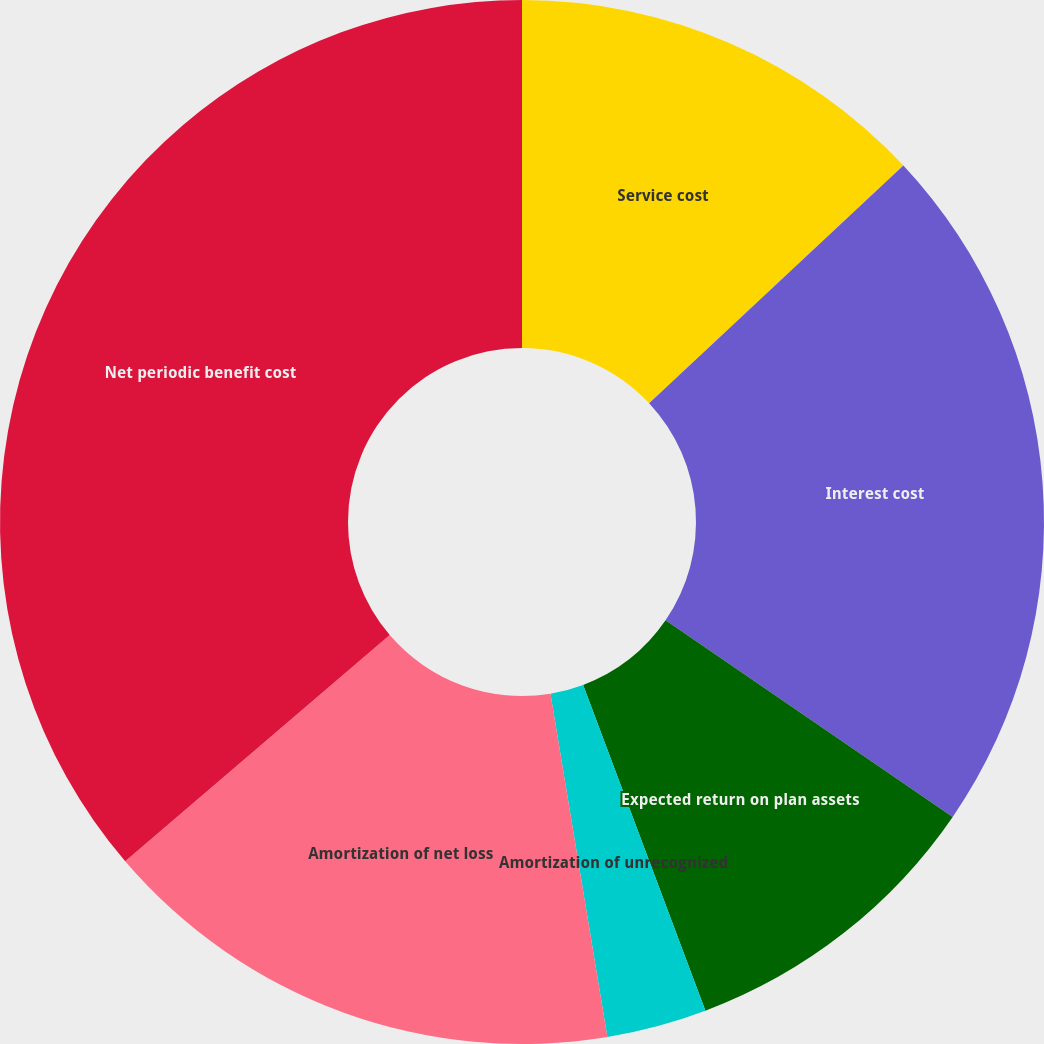<chart> <loc_0><loc_0><loc_500><loc_500><pie_chart><fcel>Service cost<fcel>Interest cost<fcel>Expected return on plan assets<fcel>Amortization of unrecognized<fcel>Amortization of net loss<fcel>Net periodic benefit cost<nl><fcel>13.04%<fcel>21.52%<fcel>9.73%<fcel>3.1%<fcel>16.36%<fcel>36.26%<nl></chart> 